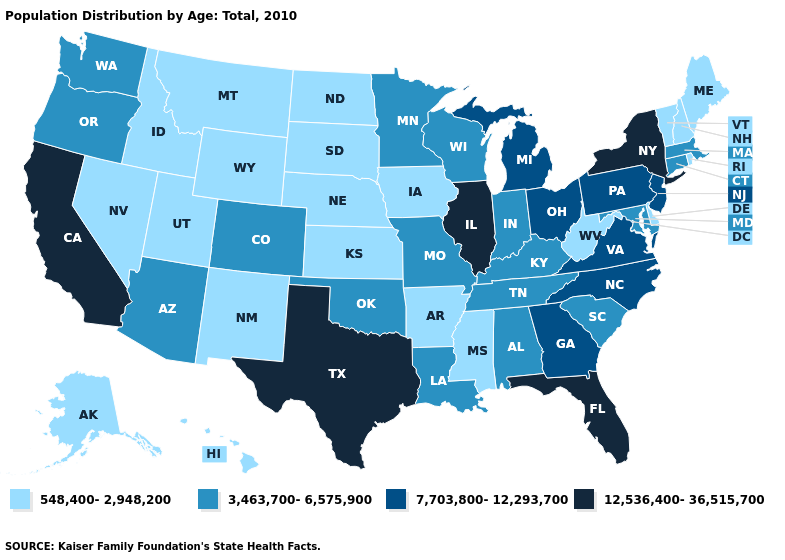Name the states that have a value in the range 548,400-2,948,200?
Answer briefly. Alaska, Arkansas, Delaware, Hawaii, Idaho, Iowa, Kansas, Maine, Mississippi, Montana, Nebraska, Nevada, New Hampshire, New Mexico, North Dakota, Rhode Island, South Dakota, Utah, Vermont, West Virginia, Wyoming. Name the states that have a value in the range 12,536,400-36,515,700?
Give a very brief answer. California, Florida, Illinois, New York, Texas. Does South Dakota have the lowest value in the MidWest?
Give a very brief answer. Yes. What is the value of Michigan?
Write a very short answer. 7,703,800-12,293,700. Name the states that have a value in the range 548,400-2,948,200?
Concise answer only. Alaska, Arkansas, Delaware, Hawaii, Idaho, Iowa, Kansas, Maine, Mississippi, Montana, Nebraska, Nevada, New Hampshire, New Mexico, North Dakota, Rhode Island, South Dakota, Utah, Vermont, West Virginia, Wyoming. What is the lowest value in states that border South Carolina?
Write a very short answer. 7,703,800-12,293,700. What is the lowest value in the South?
Give a very brief answer. 548,400-2,948,200. Does Nebraska have the lowest value in the USA?
Give a very brief answer. Yes. Name the states that have a value in the range 7,703,800-12,293,700?
Give a very brief answer. Georgia, Michigan, New Jersey, North Carolina, Ohio, Pennsylvania, Virginia. Among the states that border Montana , which have the lowest value?
Quick response, please. Idaho, North Dakota, South Dakota, Wyoming. What is the highest value in the West ?
Short answer required. 12,536,400-36,515,700. What is the highest value in states that border Minnesota?
Answer briefly. 3,463,700-6,575,900. Which states have the lowest value in the Northeast?
Give a very brief answer. Maine, New Hampshire, Rhode Island, Vermont. Among the states that border Kansas , does Missouri have the highest value?
Answer briefly. Yes. Does Mississippi have a lower value than Utah?
Give a very brief answer. No. 